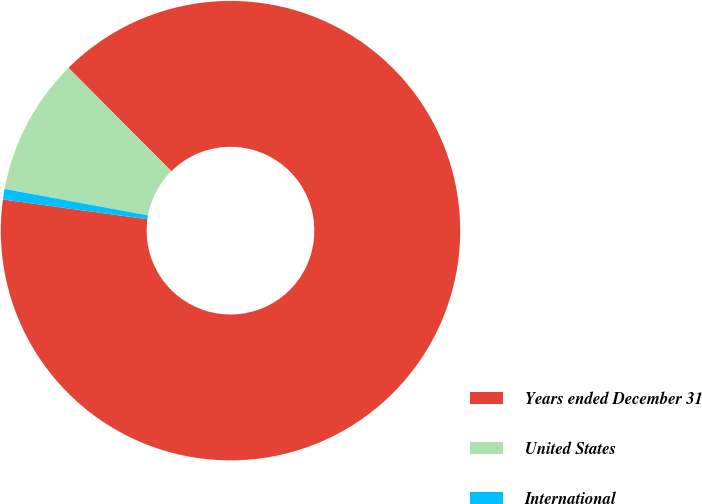Convert chart to OTSL. <chart><loc_0><loc_0><loc_500><loc_500><pie_chart><fcel>Years ended December 31<fcel>United States<fcel>International<nl><fcel>89.63%<fcel>9.63%<fcel>0.74%<nl></chart> 